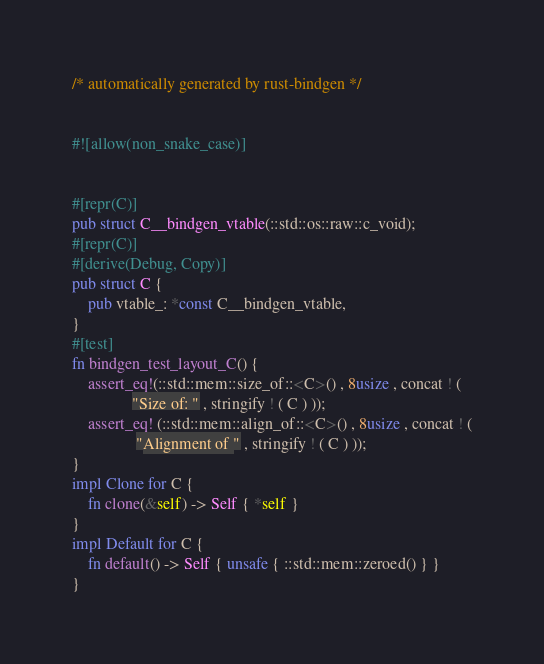<code> <loc_0><loc_0><loc_500><loc_500><_Rust_>/* automatically generated by rust-bindgen */


#![allow(non_snake_case)]


#[repr(C)]
pub struct C__bindgen_vtable(::std::os::raw::c_void);
#[repr(C)]
#[derive(Debug, Copy)]
pub struct C {
    pub vtable_: *const C__bindgen_vtable,
}
#[test]
fn bindgen_test_layout_C() {
    assert_eq!(::std::mem::size_of::<C>() , 8usize , concat ! (
               "Size of: " , stringify ! ( C ) ));
    assert_eq! (::std::mem::align_of::<C>() , 8usize , concat ! (
                "Alignment of " , stringify ! ( C ) ));
}
impl Clone for C {
    fn clone(&self) -> Self { *self }
}
impl Default for C {
    fn default() -> Self { unsafe { ::std::mem::zeroed() } }
}
</code> 